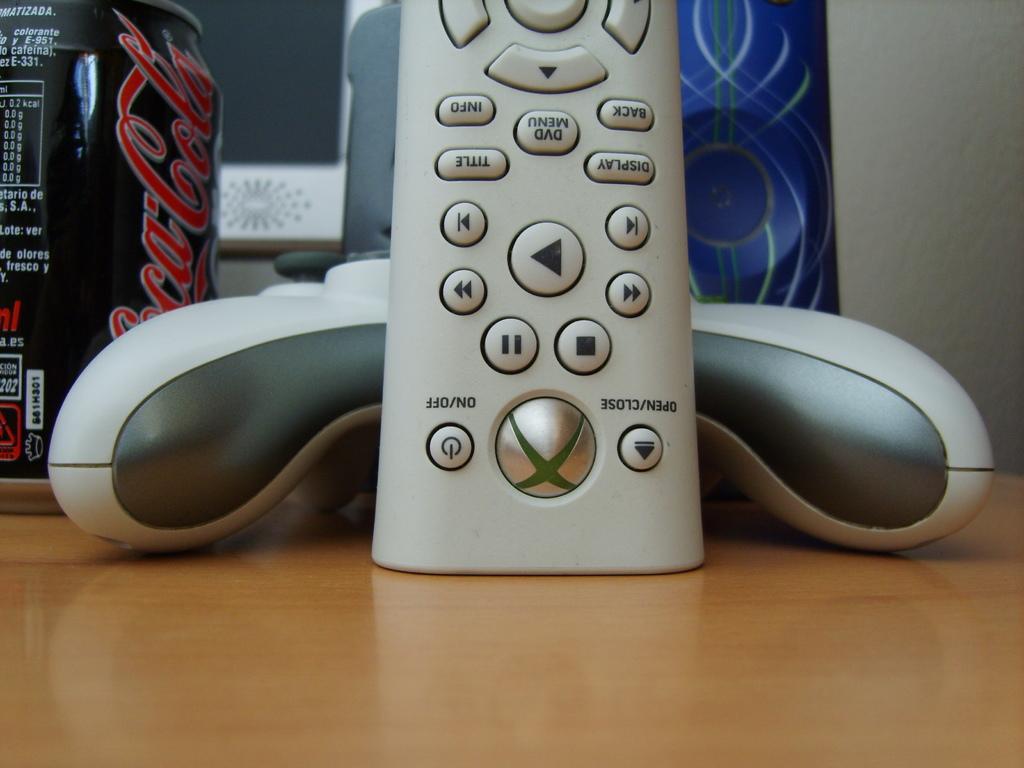Can you describe this image briefly? In this image, we can see a wooden surface, there is a remote, coke can and other objects on the wooden surface. On the right side, we can see the wall. 